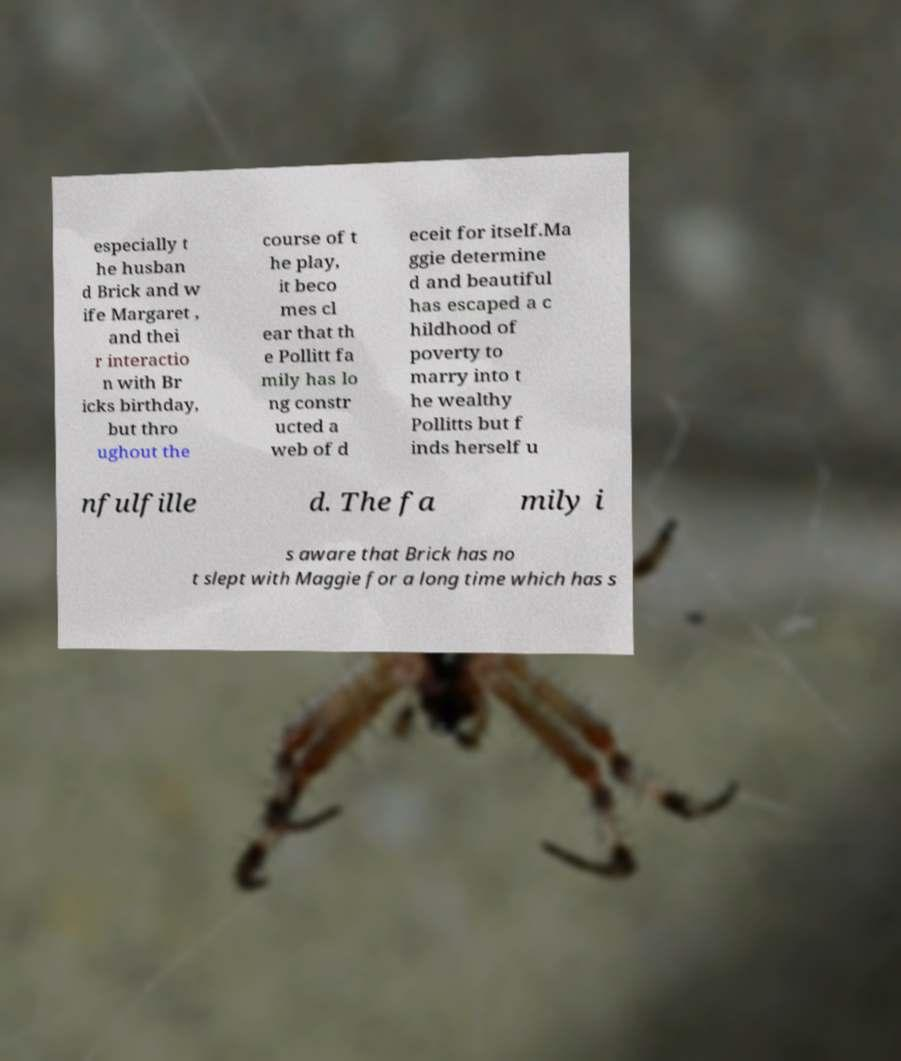There's text embedded in this image that I need extracted. Can you transcribe it verbatim? especially t he husban d Brick and w ife Margaret , and thei r interactio n with Br icks birthday, but thro ughout the course of t he play, it beco mes cl ear that th e Pollitt fa mily has lo ng constr ucted a web of d eceit for itself.Ma ggie determine d and beautiful has escaped a c hildhood of poverty to marry into t he wealthy Pollitts but f inds herself u nfulfille d. The fa mily i s aware that Brick has no t slept with Maggie for a long time which has s 